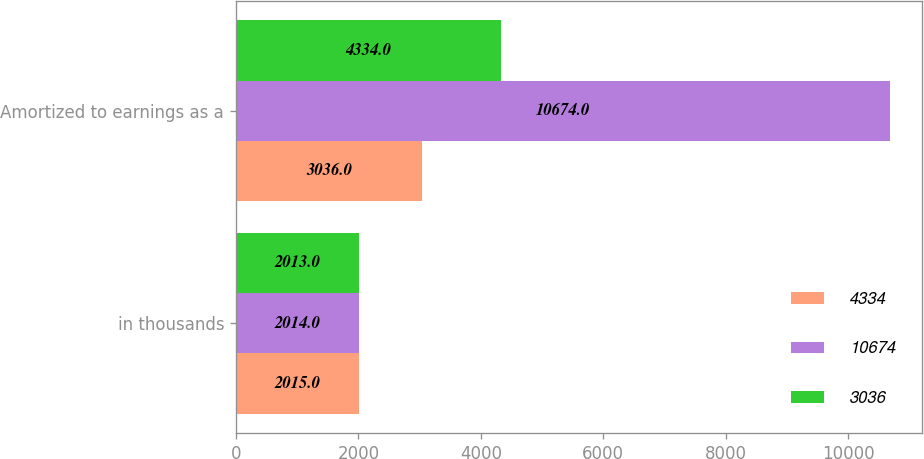Convert chart to OTSL. <chart><loc_0><loc_0><loc_500><loc_500><stacked_bar_chart><ecel><fcel>in thousands<fcel>Amortized to earnings as a<nl><fcel>4334<fcel>2015<fcel>3036<nl><fcel>10674<fcel>2014<fcel>10674<nl><fcel>3036<fcel>2013<fcel>4334<nl></chart> 